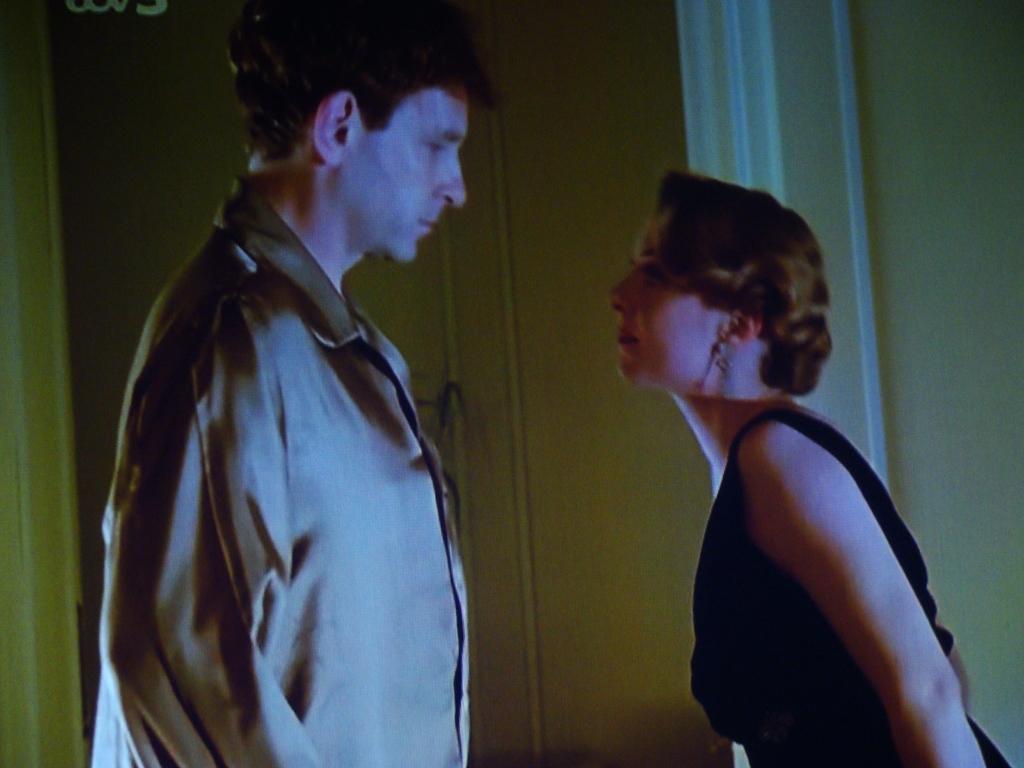Please provide a concise description of this image. On the background of the picture we can see a wall. In this picture there are two persons standing opposite to each other. On the right side of the picture we can see a women wearing a black dress and looking towards a man and this man also looking toward women. They are in eye contact with each other. 